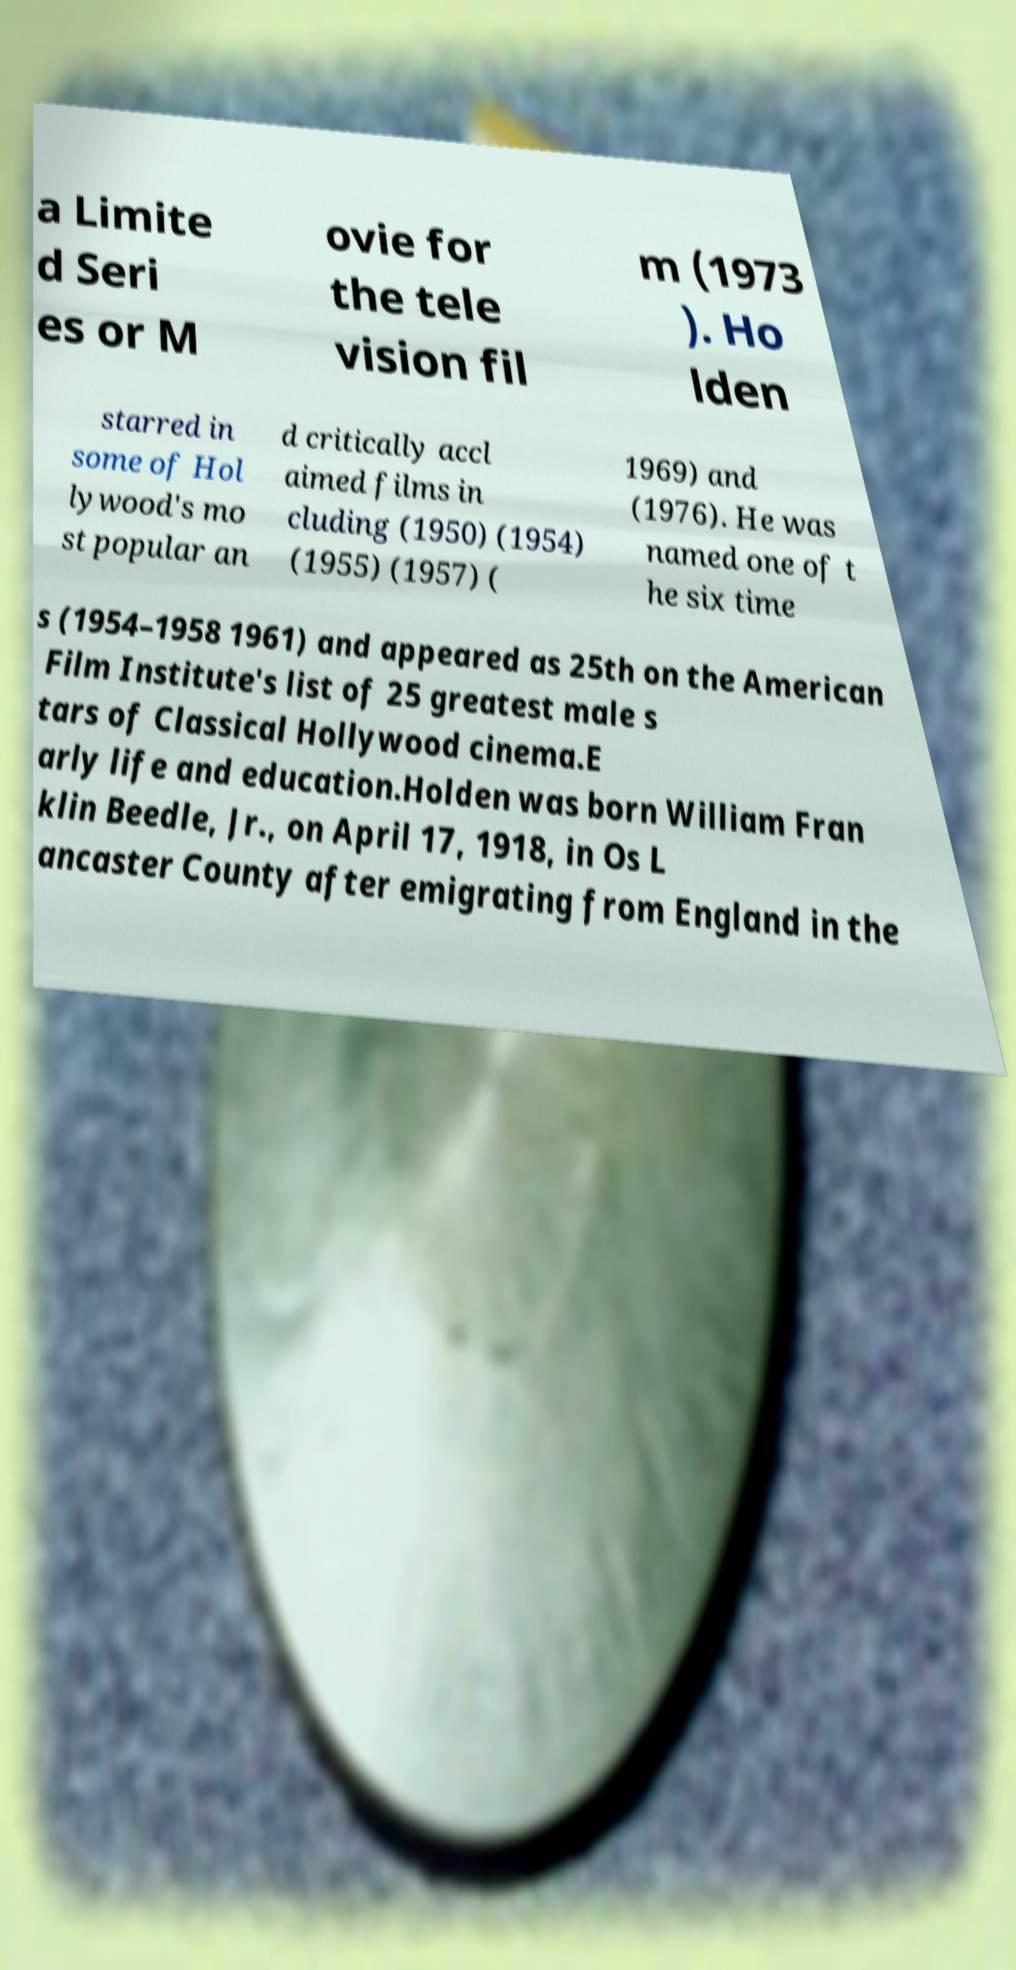There's text embedded in this image that I need extracted. Can you transcribe it verbatim? a Limite d Seri es or M ovie for the tele vision fil m (1973 ). Ho lden starred in some of Hol lywood's mo st popular an d critically accl aimed films in cluding (1950) (1954) (1955) (1957) ( 1969) and (1976). He was named one of t he six time s (1954–1958 1961) and appeared as 25th on the American Film Institute's list of 25 greatest male s tars of Classical Hollywood cinema.E arly life and education.Holden was born William Fran klin Beedle, Jr., on April 17, 1918, in Os L ancaster County after emigrating from England in the 